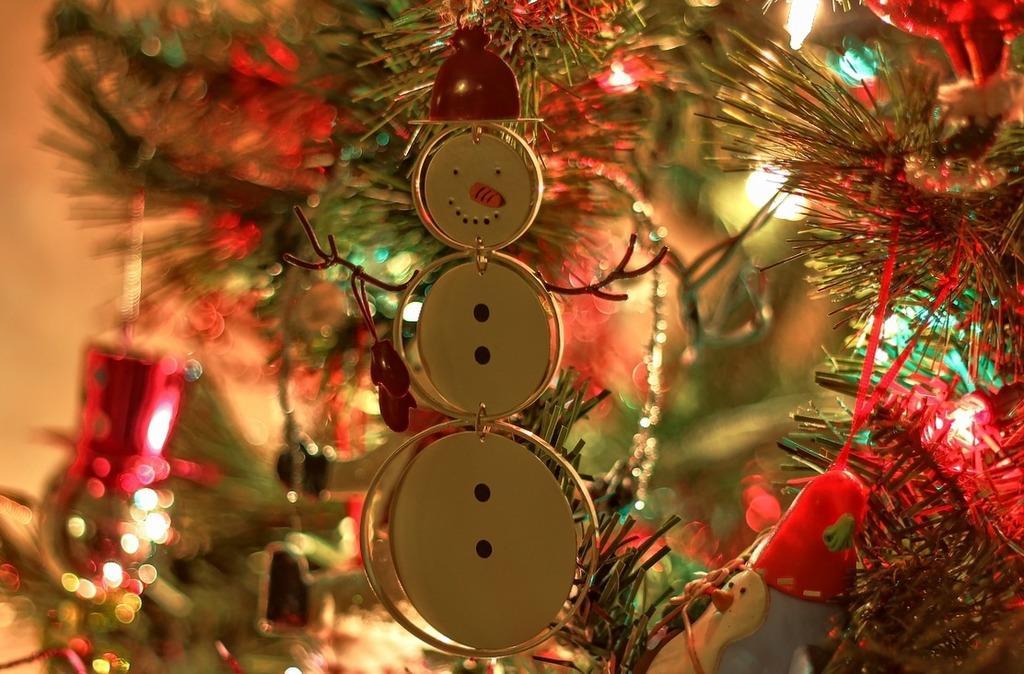Could you give a brief overview of what you see in this image? In this image there are decorative objects, a silver color object and some lighting in the background. 